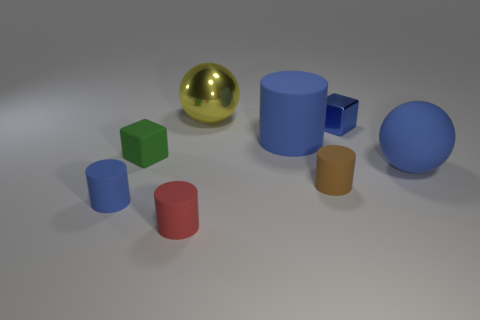Add 1 yellow balls. How many objects exist? 9 Subtract all large blue cylinders. How many cylinders are left? 3 Subtract 1 cubes. How many cubes are left? 1 Subtract all cubes. How many objects are left? 6 Subtract all gray spheres. How many brown cylinders are left? 1 Subtract all blue balls. How many balls are left? 1 Subtract all brown blocks. Subtract all green cylinders. How many blocks are left? 2 Subtract all brown matte cylinders. Subtract all small red matte objects. How many objects are left? 6 Add 3 tiny green cubes. How many tiny green cubes are left? 4 Add 1 small brown matte cylinders. How many small brown matte cylinders exist? 2 